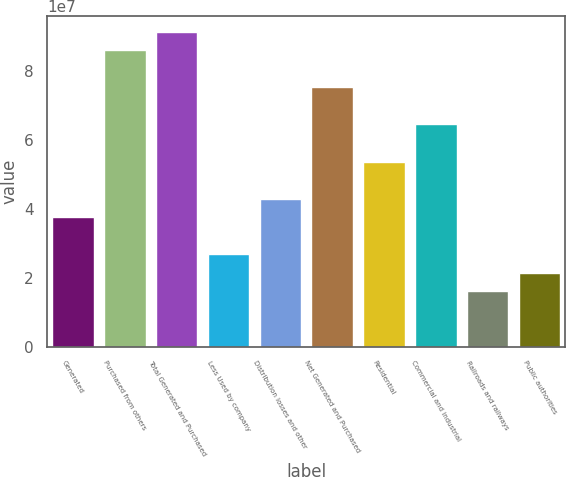Convert chart to OTSL. <chart><loc_0><loc_0><loc_500><loc_500><bar_chart><fcel>Generated<fcel>Purchased from others<fcel>Total Generated and Purchased<fcel>Less Used by company<fcel>Distribution losses and other<fcel>Net Generated and Purchased<fcel>Residential<fcel>Commercial and industrial<fcel>Railroads and railways<fcel>Public authorities<nl><fcel>3.76145e+07<fcel>8.5976e+07<fcel>9.13495e+07<fcel>2.68675e+07<fcel>4.2988e+07<fcel>7.5229e+07<fcel>5.3735e+07<fcel>6.4482e+07<fcel>1.61205e+07<fcel>2.1494e+07<nl></chart> 